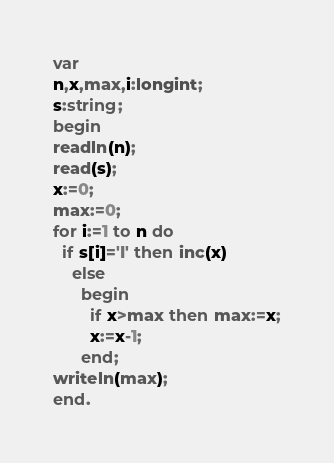<code> <loc_0><loc_0><loc_500><loc_500><_Pascal_>var
n,x,max,i:longint;
s:string;
begin
readln(n);
read(s);
x:=0;
max:=0;
for i:=1 to n do
  if s[i]='I' then inc(x)
    else
      begin
        if x>max then max:=x;
        x:=x-1;
      end;
writeln(max);
end.</code> 